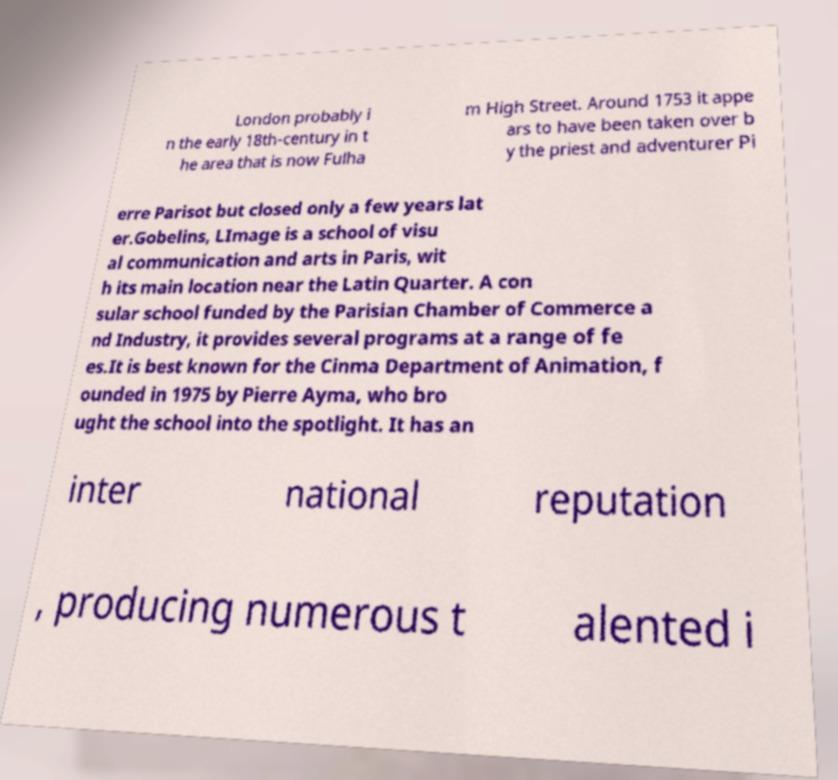Please identify and transcribe the text found in this image. London probably i n the early 18th-century in t he area that is now Fulha m High Street. Around 1753 it appe ars to have been taken over b y the priest and adventurer Pi erre Parisot but closed only a few years lat er.Gobelins, LImage is a school of visu al communication and arts in Paris, wit h its main location near the Latin Quarter. A con sular school funded by the Parisian Chamber of Commerce a nd Industry, it provides several programs at a range of fe es.It is best known for the Cinma Department of Animation, f ounded in 1975 by Pierre Ayma, who bro ught the school into the spotlight. It has an inter national reputation , producing numerous t alented i 